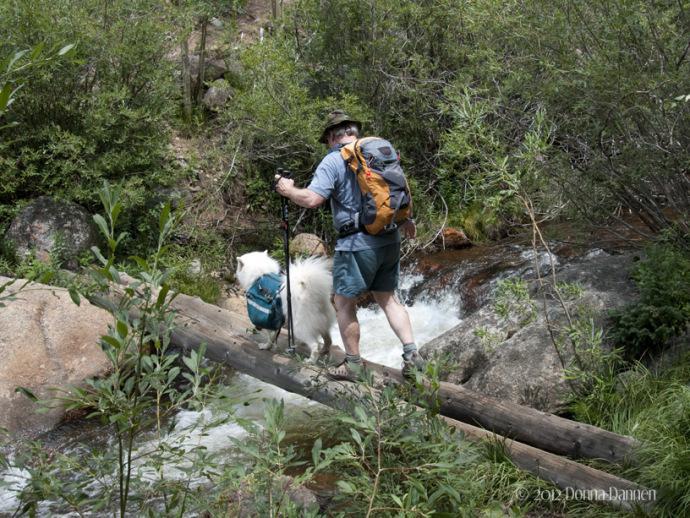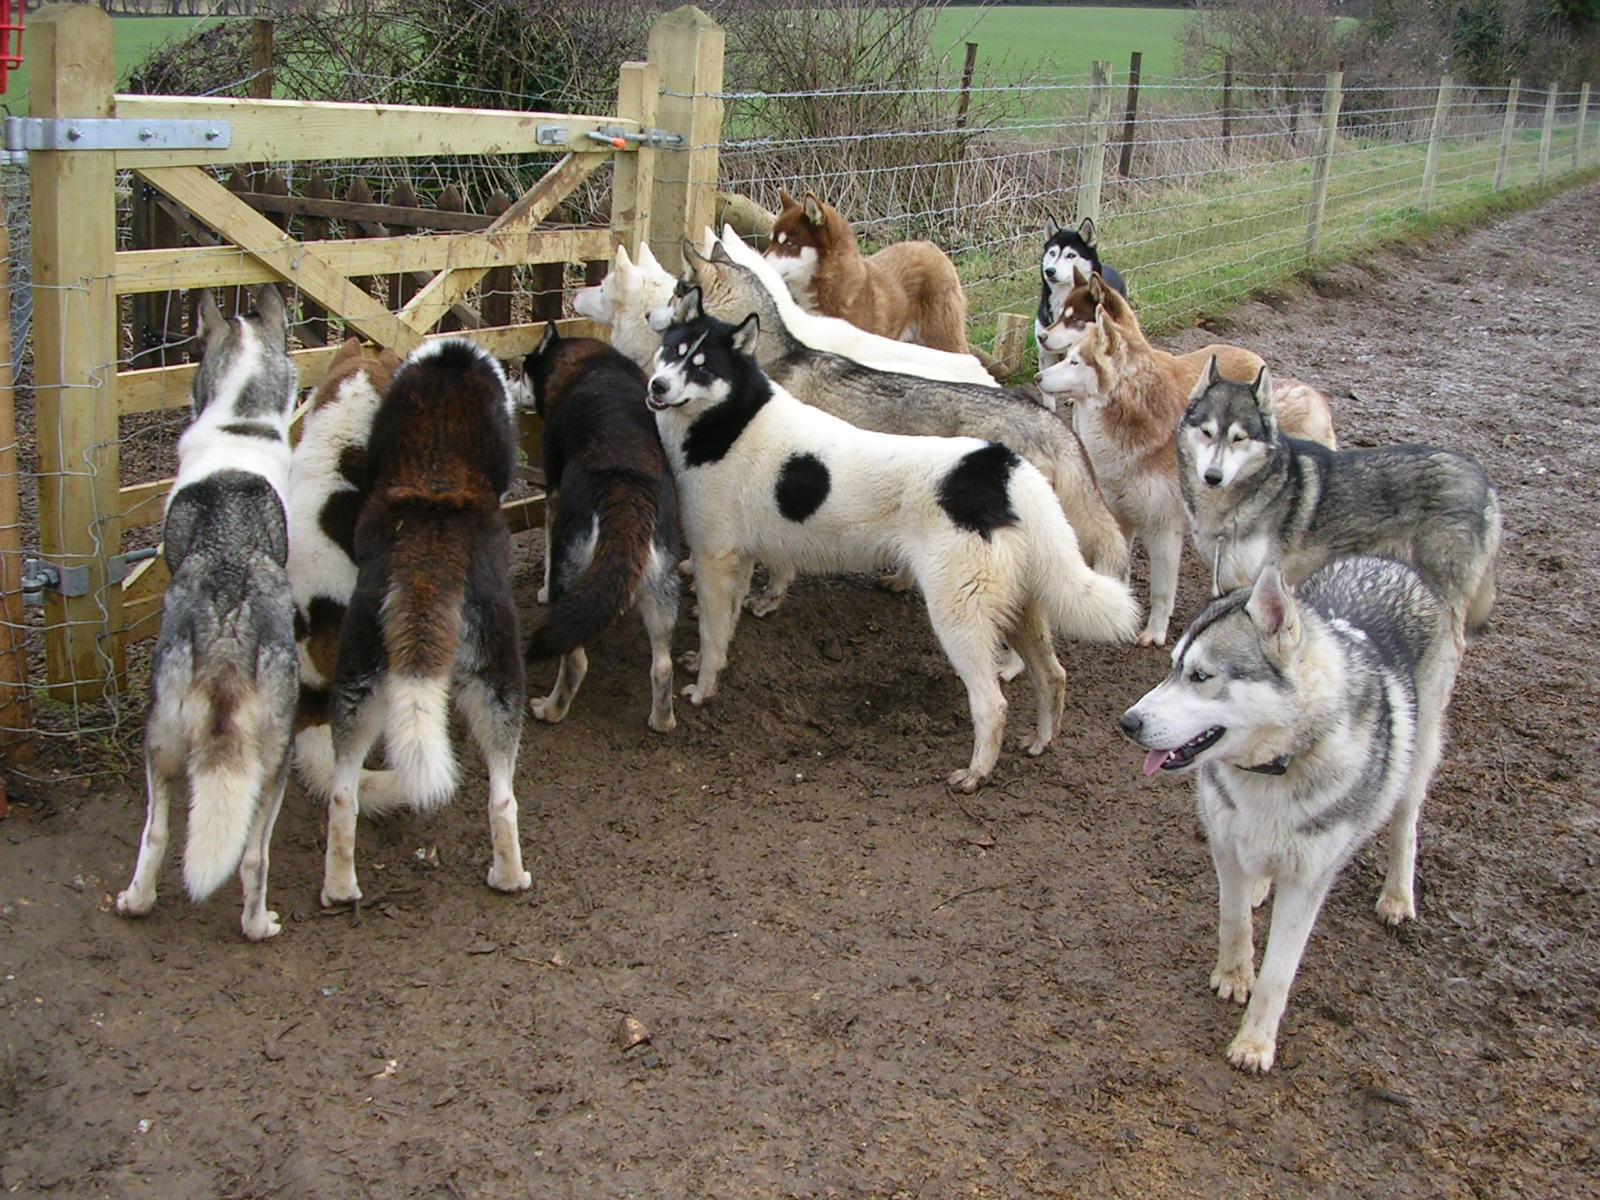The first image is the image on the left, the second image is the image on the right. Given the left and right images, does the statement "A man is accompanied by a dog, and in one of the photos they are walking across a large log." hold true? Answer yes or no. Yes. The first image is the image on the left, the second image is the image on the right. Given the left and right images, does the statement "there is a dog wearing a back pack" hold true? Answer yes or no. Yes. 